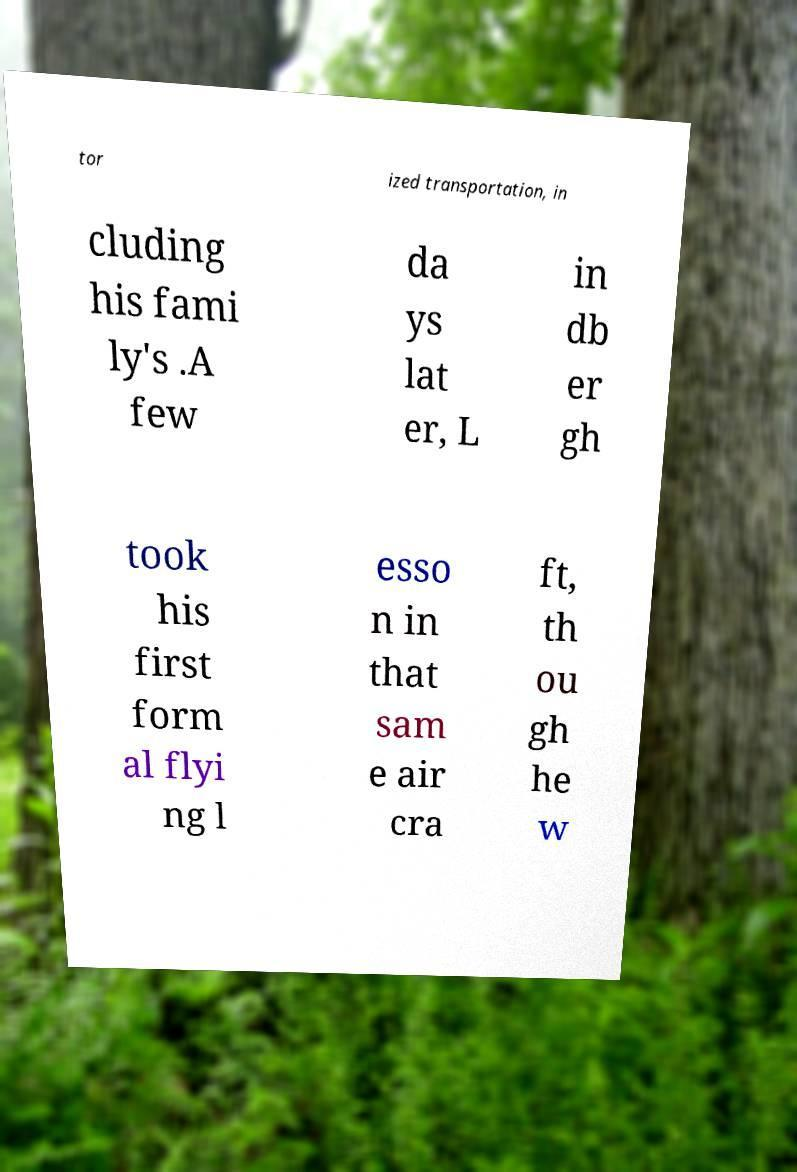I need the written content from this picture converted into text. Can you do that? tor ized transportation, in cluding his fami ly's .A few da ys lat er, L in db er gh took his first form al flyi ng l esso n in that sam e air cra ft, th ou gh he w 